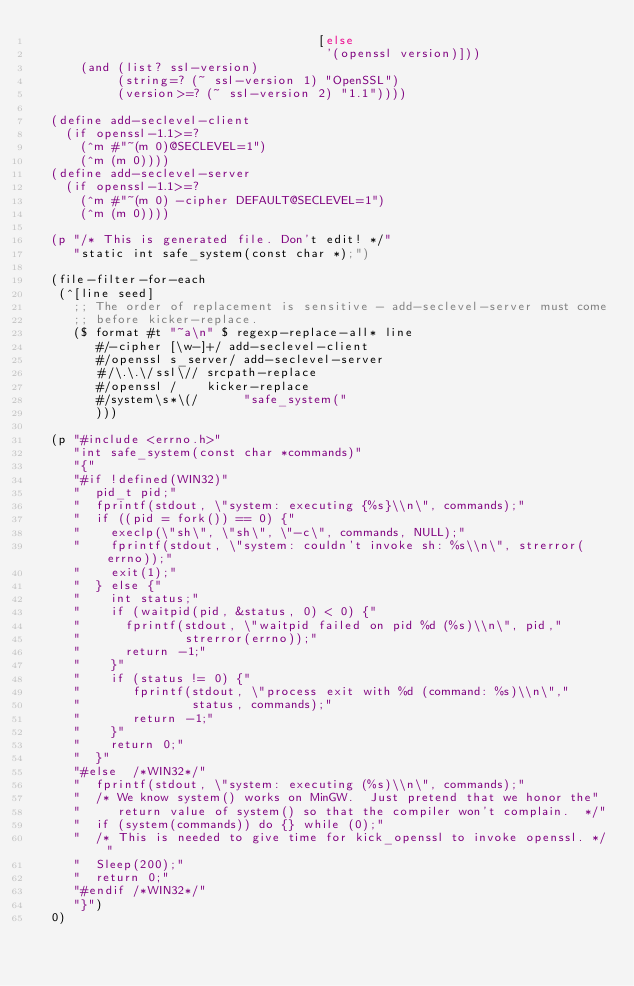<code> <loc_0><loc_0><loc_500><loc_500><_Scheme_>                                      [else
                                       '(openssl version)]))
      (and (list? ssl-version)
           (string=? (~ ssl-version 1) "OpenSSL")
           (version>=? (~ ssl-version 2) "1.1"))))

  (define add-seclevel-client
    (if openssl-1.1>=?
      (^m #"~(m 0)@SECLEVEL=1")
      (^m (m 0))))
  (define add-seclevel-server
    (if openssl-1.1>=?
      (^m #"~(m 0) -cipher DEFAULT@SECLEVEL=1")
      (^m (m 0))))

  (p "/* This is generated file. Don't edit! */"
     "static int safe_system(const char *);")

  (file-filter-for-each
   (^[line seed]
     ;; The order of replacement is sensitive - add-seclevel-server must come
     ;; before kicker-replace.
     ($ format #t "~a\n" $ regexp-replace-all* line
        #/-cipher [\w-]+/ add-seclevel-client
        #/openssl s_server/ add-seclevel-server
        #/\.\.\/ssl\// srcpath-replace
        #/openssl /    kicker-replace
        #/system\s*\(/      "safe_system("
        )))

  (p "#include <errno.h>"
     "int safe_system(const char *commands)"
     "{"
     "#if !defined(WIN32)"
     "  pid_t pid;"
     "  fprintf(stdout, \"system: executing {%s}\\n\", commands);"
     "  if ((pid = fork()) == 0) {"
     "    execlp(\"sh\", \"sh\", \"-c\", commands, NULL);"
     "    fprintf(stdout, \"system: couldn't invoke sh: %s\\n\", strerror(errno));"
     "    exit(1);"
     "  } else {"
     "    int status;"
     "    if (waitpid(pid, &status, 0) < 0) {"
     "      fprintf(stdout, \"waitpid failed on pid %d (%s)\\n\", pid,"
     "              strerror(errno));"
     "      return -1;"
     "    }"
     "    if (status != 0) {"
     "       fprintf(stdout, \"process exit with %d (command: %s)\\n\","
     "               status, commands);"
     "       return -1;"
     "    }"
     "    return 0;"
     "  }"
     "#else  /*WIN32*/"
     "  fprintf(stdout, \"system: executing (%s)\\n\", commands);"
     "  /* We know system() works on MinGW.  Just pretend that we honor the"
     "     return value of system() so that the compiler won't complain.  */"
     "  if (system(commands)) do {} while (0);"
     "  /* This is needed to give time for kick_openssl to invoke openssl. */"
     "  Sleep(200);"
     "  return 0;"
     "#endif /*WIN32*/"
     "}")
  0)
</code> 